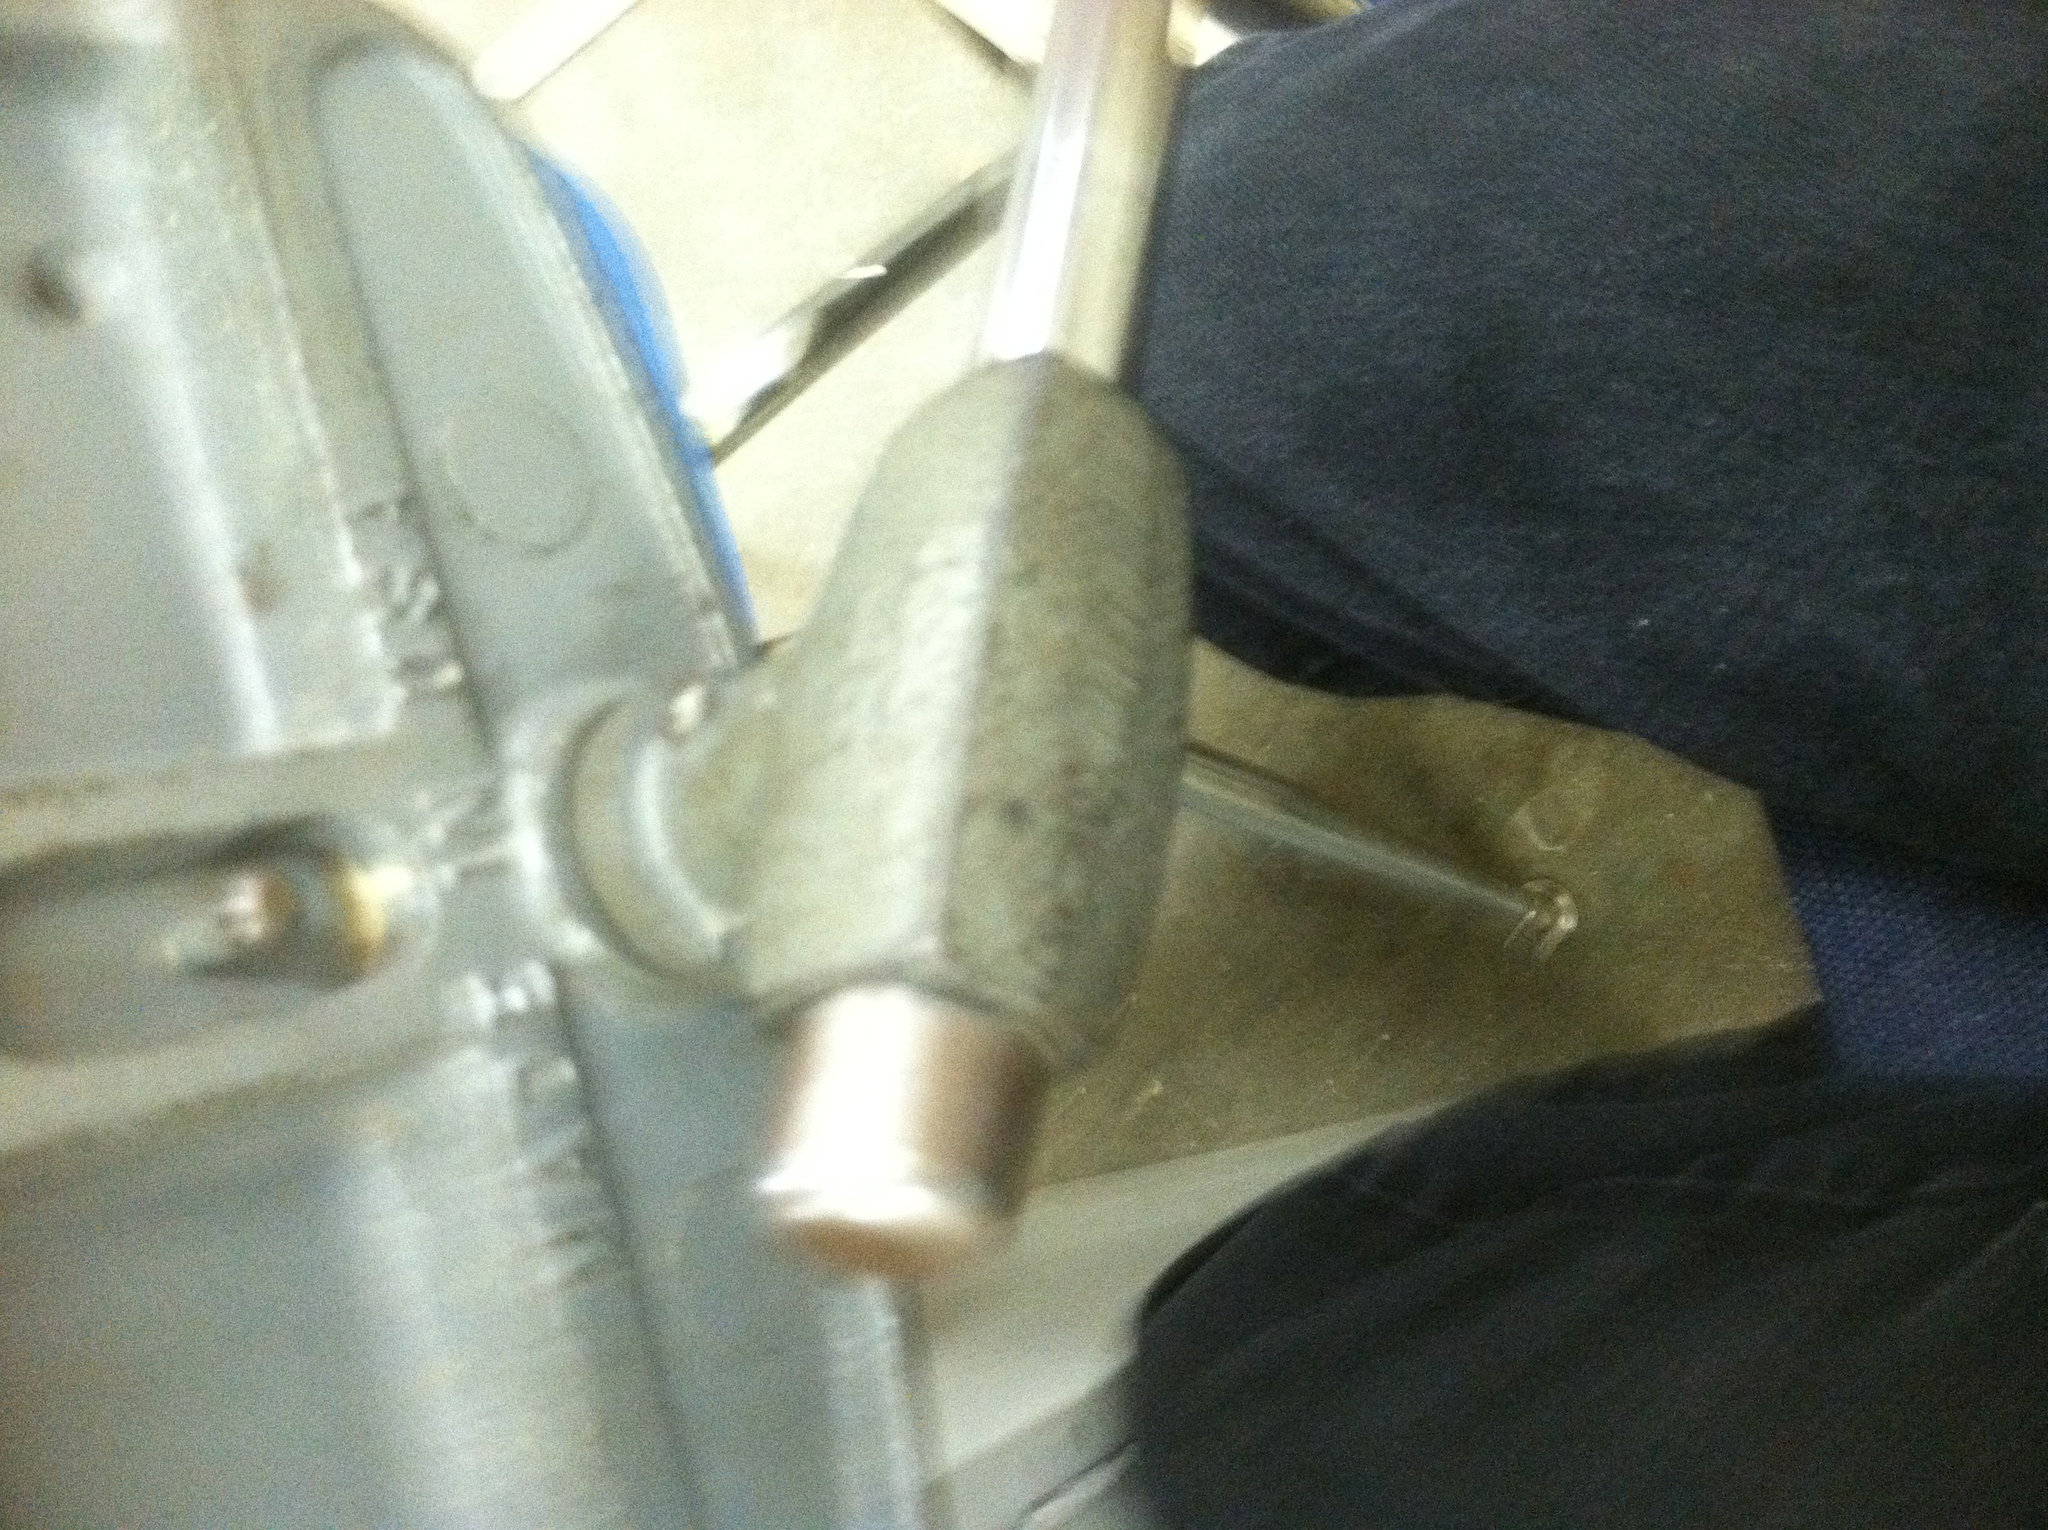What type of tool is this? This appears to be a vise, a type of tool used to secure an object firmly in place while work is being done on it. Vises are essential in metalworking, woodworking, and other tasks that require stability and precision. 